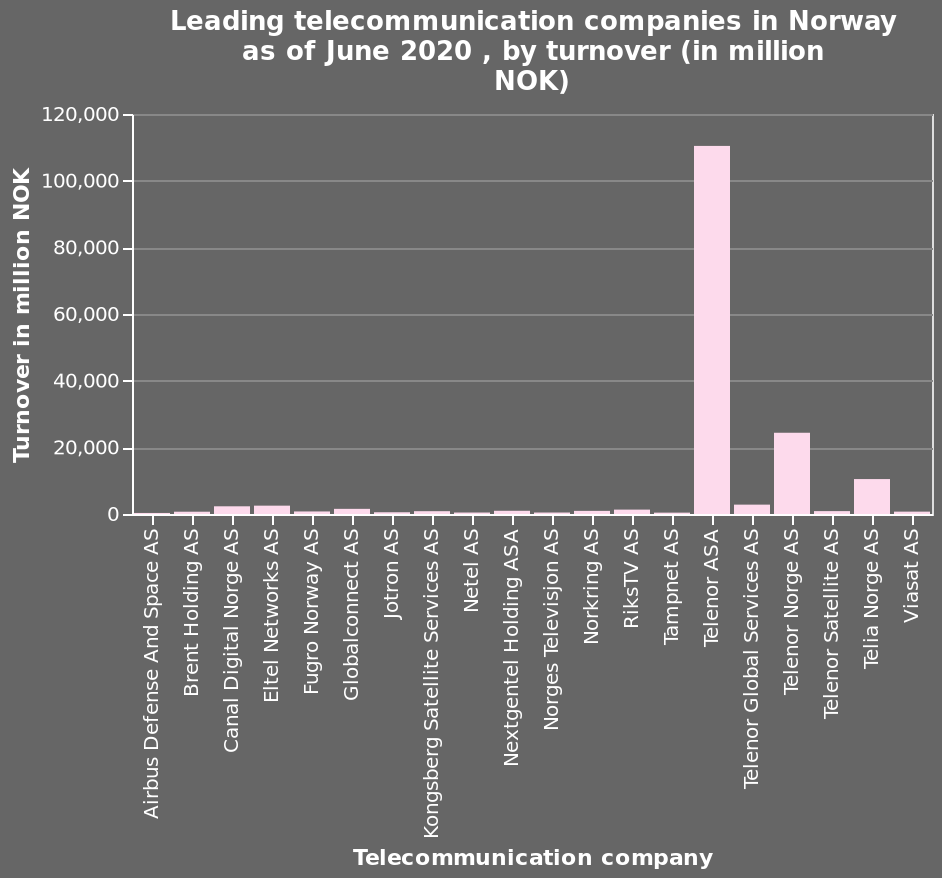<image>
Is there a company with a significantly higher turnover than the rest? Yes, there is one company in particular that has a huge turnover compared to the rest. please enumerates aspects of the construction of the chart This is a bar plot named Leading telecommunication companies in Norway as of June 2020 , by turnover (in million NOK). Turnover in million NOK is measured on the y-axis. Telecommunication company is drawn on the x-axis. What is represented on the x-axis of the bar plot? The x-axis of the bar plot represents the telecommunication companies. please summary the statistics and relations of the chart The Norwegian market is dominated by a few operators. 